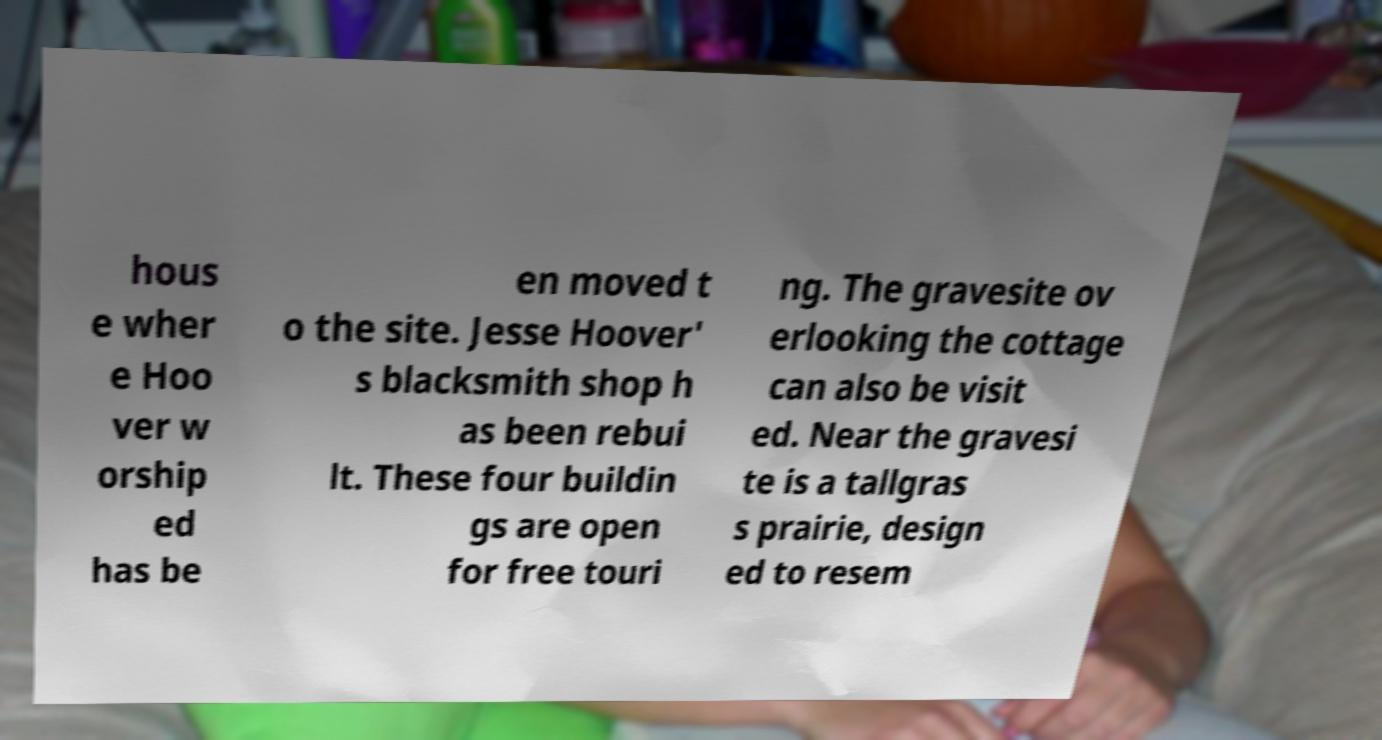Could you extract and type out the text from this image? hous e wher e Hoo ver w orship ed has be en moved t o the site. Jesse Hoover' s blacksmith shop h as been rebui lt. These four buildin gs are open for free touri ng. The gravesite ov erlooking the cottage can also be visit ed. Near the gravesi te is a tallgras s prairie, design ed to resem 